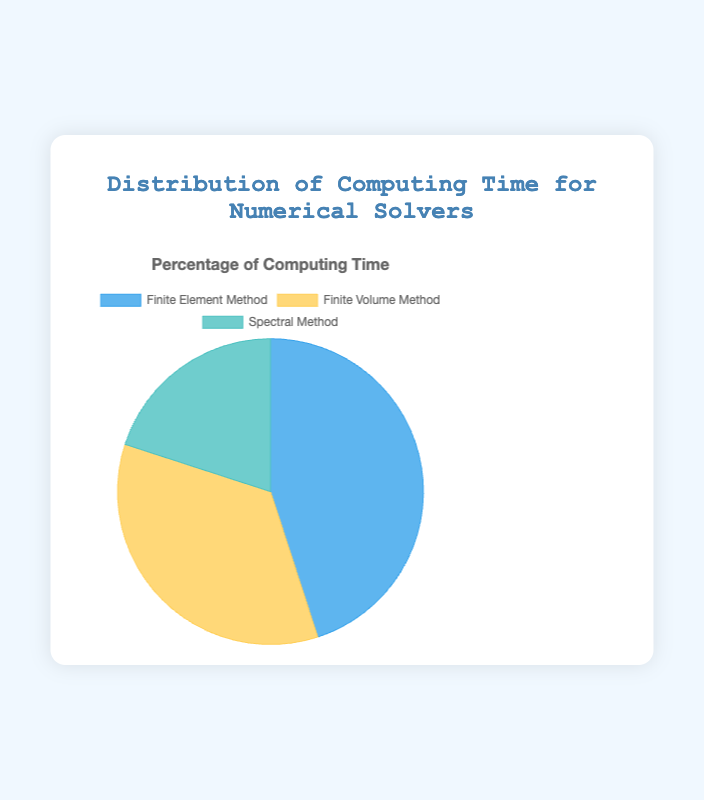What percentage of computing time is spent on the Finite Volume Method? Refer to the pie chart where the slice representing the Finite Volume Method shows 35%.
Answer: 35% Which solver consumes the most computing time? By examining the pie chart, the largest segment represents the Finite Element Method at 45%.
Answer: Finite Element Method What is the combined percentage of computing time spent on the Finite Volume Method and Spectral Method? Add the percentages of Finite Volume Method (35%) and Spectral Method (20%) to get 35 + 20 = 55%.
Answer: 55% Which method consumes less computing time: Finite Element Method or Spectral Method, and by how much? The Finite Element Method consumes 45%, and the Spectral Method consumes 20%. The difference is 45 - 20 = 25%.
Answer: Spectral Method consumes 25% less What is the average percentage of computing time spent across all three methods? Add the percentages for Finite Element Method (45%), Finite Volume Method (35%), and Spectral Method (20%), then divide by 3. (45 + 35 + 20) / 3 = 100 / 3 ≈ 33.33%.
Answer: 33.33% Which solver occupies the smallest portion of the pie chart? Observing the pie chart, the smallest segment corresponds to the Spectral Method at 20%.
Answer: Spectral Method How much more computing time does the Finite Volume Method take compared to the Spectral Method? Subtract the Spectral Method percentage (20%) from the Finite Volume Method percentage (35%). 35 - 20 = 15%.
Answer: 15% What is the ratio of computing time between the Finite Element Method and the Spectral Method? The Finite Element Method is 45% and the Spectral Method is 20%. The ratio is 45:20, which simplifies to 9:4.
Answer: 9:4 If the total projected working hours for these solvers in a month is 200 hours, how many hours are spent on the Finite Element Method? Calculate 45% of 200 hours. 0.45 * 200 = 90 hours.
Answer: 90 hours 